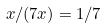<formula> <loc_0><loc_0><loc_500><loc_500>x / ( 7 x ) = 1 / 7</formula> 